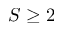<formula> <loc_0><loc_0><loc_500><loc_500>S \geq 2</formula> 